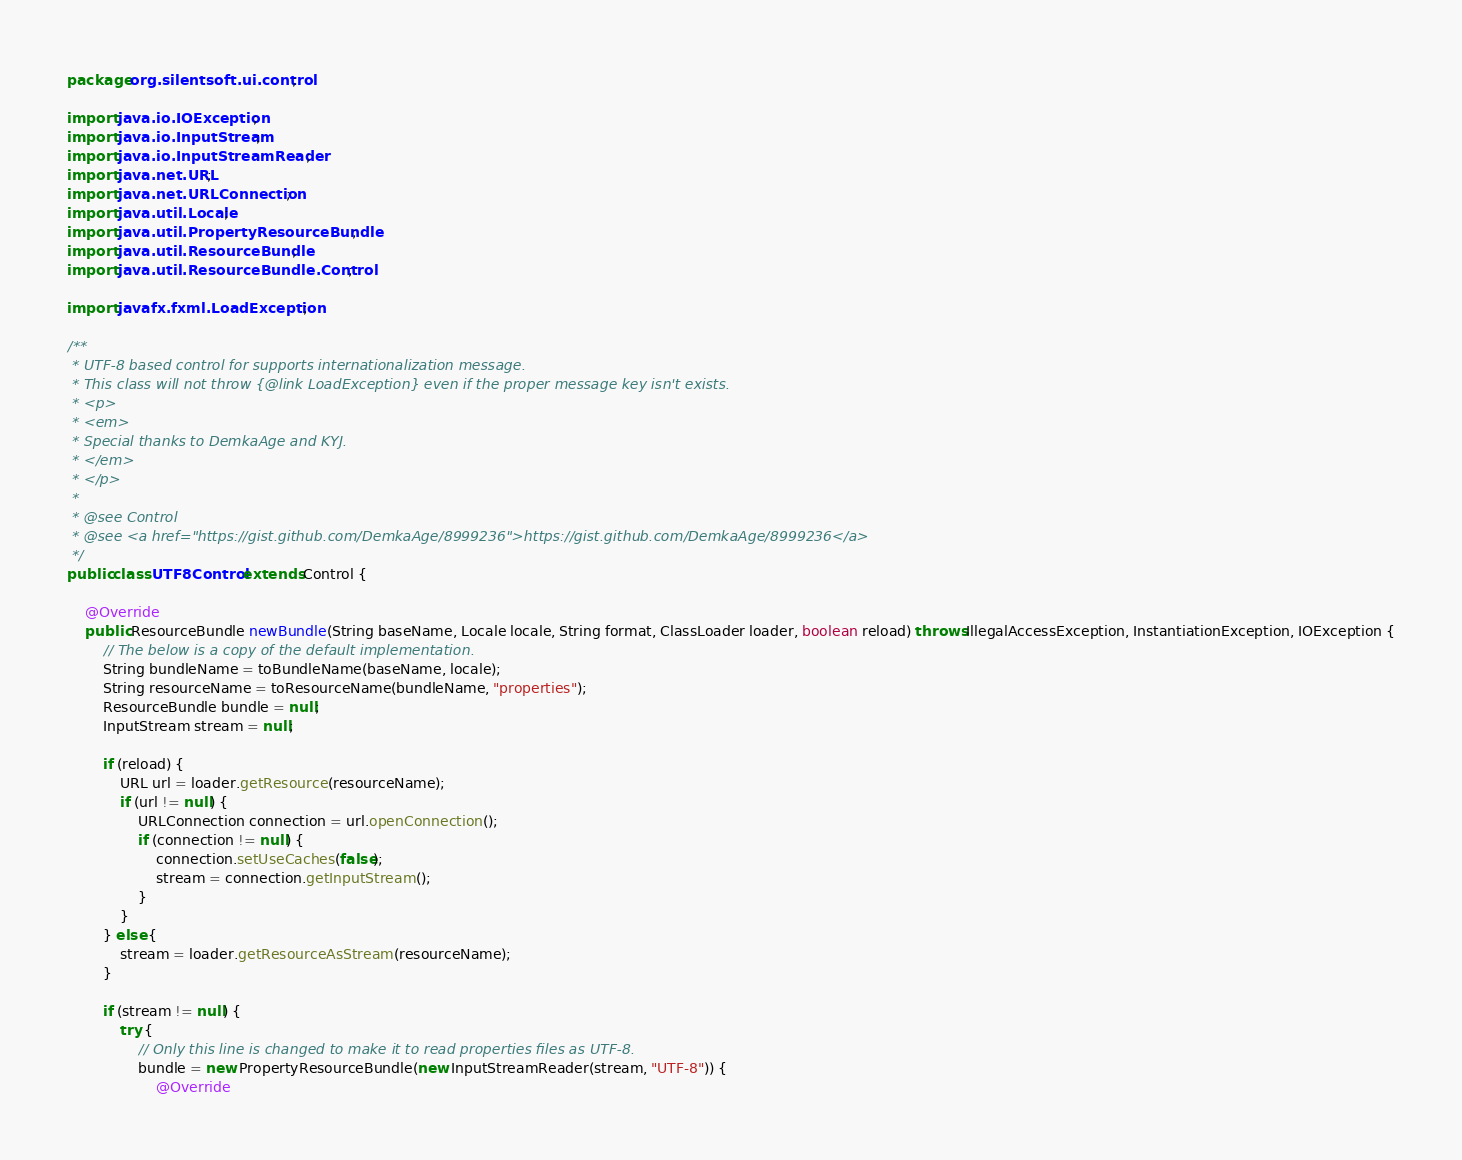Convert code to text. <code><loc_0><loc_0><loc_500><loc_500><_Java_>package org.silentsoft.ui.control;

import java.io.IOException;
import java.io.InputStream;
import java.io.InputStreamReader;
import java.net.URL;
import java.net.URLConnection;
import java.util.Locale;
import java.util.PropertyResourceBundle;
import java.util.ResourceBundle;
import java.util.ResourceBundle.Control;

import javafx.fxml.LoadException;

/**
 * UTF-8 based control for supports internationalization message.
 * This class will not throw {@link LoadException} even if the proper message key isn't exists.
 * <p>
 * <em>
 * Special thanks to DemkaAge and KYJ.
 * </em>
 * </p>
 * 
 * @see Control
 * @see <a href="https://gist.github.com/DemkaAge/8999236">https://gist.github.com/DemkaAge/8999236</a>
 */
public class UTF8Control extends Control {

	@Override
	public ResourceBundle newBundle(String baseName, Locale locale, String format, ClassLoader loader, boolean reload) throws IllegalAccessException, InstantiationException, IOException {
		// The below is a copy of the default implementation.
        String bundleName = toBundleName(baseName, locale);
        String resourceName = toResourceName(bundleName, "properties");
        ResourceBundle bundle = null;
        InputStream stream = null;
        
        if (reload) {
            URL url = loader.getResource(resourceName);
            if (url != null) {
                URLConnection connection = url.openConnection();
                if (connection != null) {
                    connection.setUseCaches(false);
                    stream = connection.getInputStream();
                }
            }
        } else {
            stream = loader.getResourceAsStream(resourceName);
        }
        
        if (stream != null) {
            try {
                // Only this line is changed to make it to read properties files as UTF-8.
                bundle = new PropertyResourceBundle(new InputStreamReader(stream, "UTF-8")) {
                	@Override</code> 